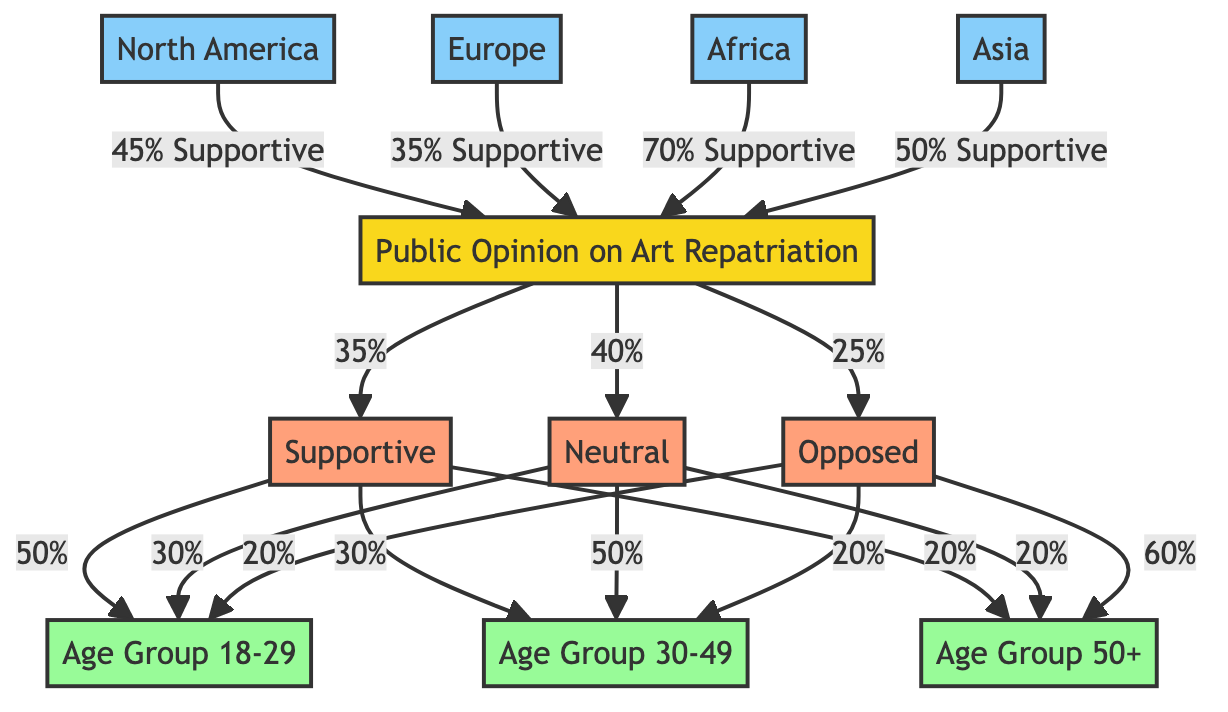What percentage of people are supportive of art repatriation? The diagram shows that 35% of the overall public opinion is supportive of art repatriation. This percentage is shown as an edge stemming from the main node "Public Opinion on Art Repatriation" leading to the node "Supportive."
Answer: 35% What percentage of people in the age group 50+ are opposed to art repatriation? According to the diagram, 60% of people in the age group 50+ indicated that they are opposed to art repatriation. This is indicated by the edge from "Opposed" to "Age Group 50+" showing the percentage.
Answer: 60% Which demographic group has the highest support for art repatriation? The diagram illustrates that the demographic group "Africa" has the highest support for art repatriation at 70%. This is shown by the edge connecting the region "Africa" to the main node with the percentage labeled.
Answer: 70% What is the percentage of neutral opinions from the age group 30-49? The diagram indicates that 50% of the age group 30-49 expressed a neutral opinion regarding art repatriation. This information is derived from the edge leading from "Neutral" to "Age Group 30-49."
Answer: 50% Which region has the same percentage of support for art repatriation as Europe? The South America region and Europe both show a supportive percentage of 35%. The answer is reached by identifying both regions' edges connecting to the main node with the same percentage labeled.
Answer: Europe What is the overall percentage of people who oppose art repatriation? The diagram states that 25% of people overall are opposed to art repatriation. This is represented as an edge connecting the main node "Public Opinion on Art Repatriation" to the node "Opposed."
Answer: 25% Which age group has the lowest percentage of support for art repatriation? The age group 50+ has the lowest percentage of support for art repatriation, which is 20%. This is deduced from observing the relationships stemming from "Supportive" to "Age Group 50+" and finding the lowest percentage.
Answer: 20% What percentage of people under 30 are neutral in their opinion on art repatriation? From the diagram, it indicates that 30% of the age group 18-29 are neutral towards art repatriation. This is shown by looking at the edge leading from "Neutral" to "Age Group 18-29."
Answer: 30% 